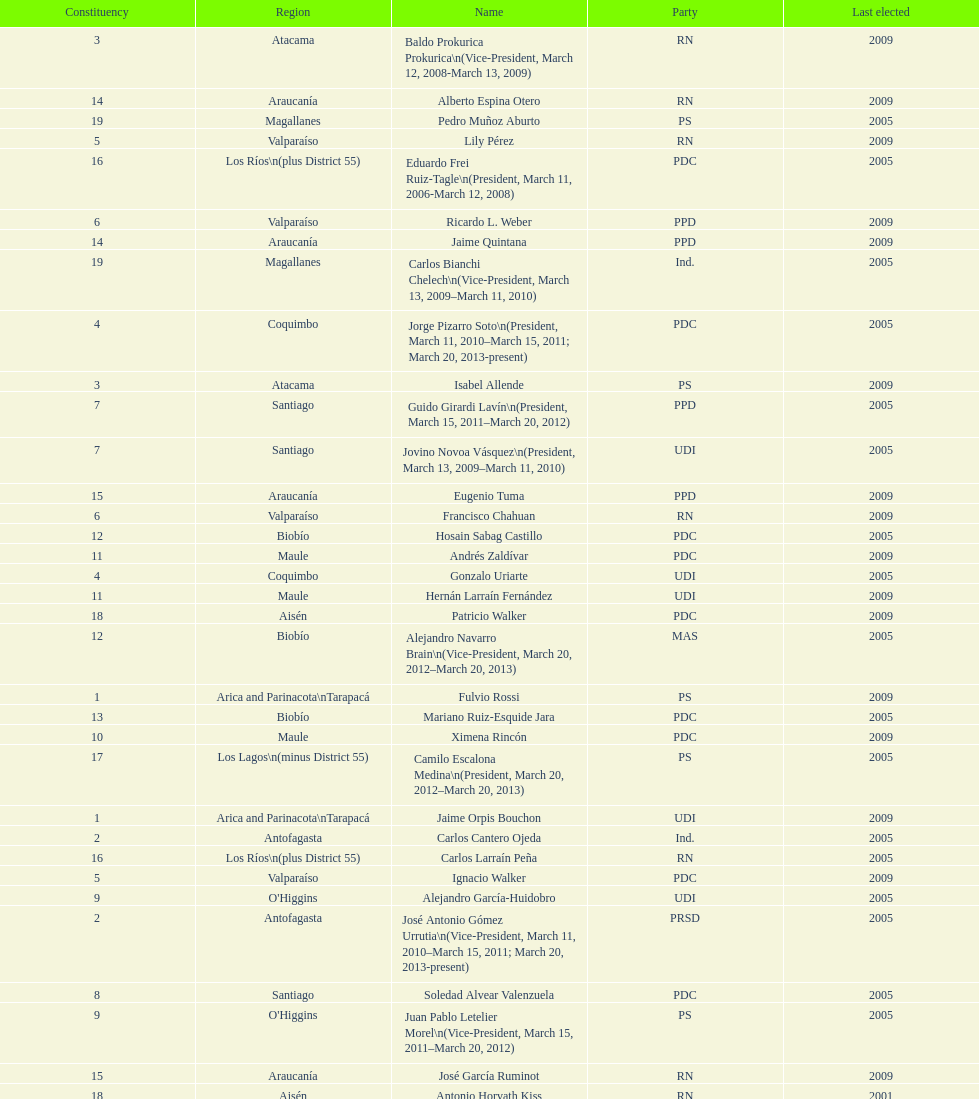How many total consituency are listed in the table? 19. 